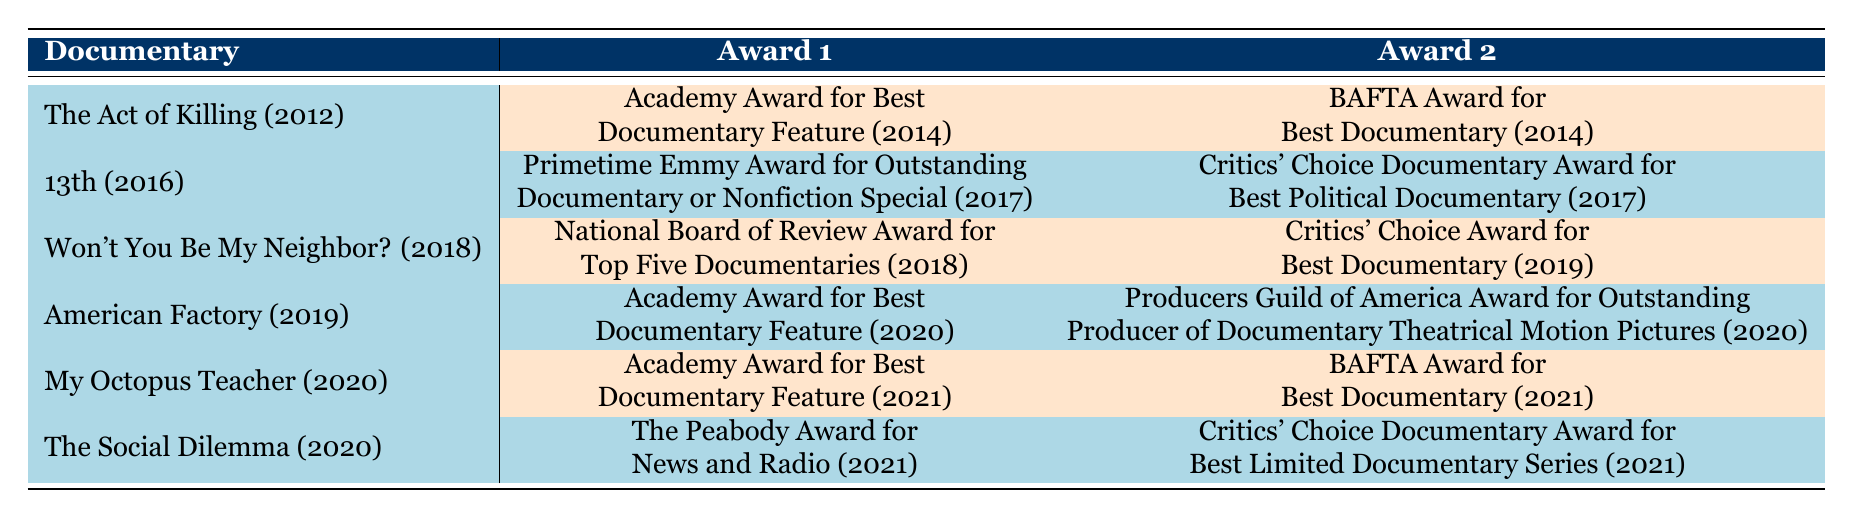What is the title of the documentary that won the Academy Award for Best Documentary Feature in 2021? From the table, the documentary that won the Academy Award for Best Documentary Feature in 2021 is "My Octopus Teacher."
Answer: My Octopus Teacher How many awards did "American Factory" win? "American Factory" has two awards listed: the Academy Award for Best Documentary Feature in 2020 and the Producers Guild of America Award for Outstanding Producer of Documentary Theatrical Motion Pictures in 2020.
Answer: 2 Did "The Social Dilemma" win a BAFTA Award? Based on the data, "The Social Dilemma" does not have a BAFTA Award listed; instead, it won a Peabody Award and a Critics' Choice Documentary Award.
Answer: No Which documentary received the Critics' Choice Award for Best Documentary in 2019? The only documentary listed with a Critics' Choice Award for Best Documentary in 2019 is "Won't You Be My Neighbor?" from 2018.
Answer: Won't You Be My Neighbor? What is the average number of awards won by documentaries released between 2012 and 2020? Summing the total awards won: "The Act of Killing" (2), "13th" (2), "Won't You Be My Neighbor?" (2), "American Factory" (2), "My Octopus Teacher" (2), and "The Social Dilemma" (2) gives us 12 awards across 6 documentaries. The average is 12 awards / 6 documentaries = 2 awards per documentary.
Answer: 2 Which year saw the highest number of documentaries winning two awards each? The year 2021 saw both "My Octopus Teacher" and "The Social Dilemma" winning two awards each. No other year in the table has two documentaries winning two awards.
Answer: 2021 Was there any documentary in the table that won awards in both 2019 and 2020? By examining the table, "American Factory" won awards in 2020, while "Won't You Be My Neighbor?" won in 2018 and did not win in 2019 or 2020. Thus, there are no documentaries winning awards in both years.
Answer: No Can you identify the earliest-shown documentary that won an award? The earliest documentary listed is "The Act of Killing," which received its awards in 2014. It is the first documentary in the table that won an award.
Answer: The Act of Killing 